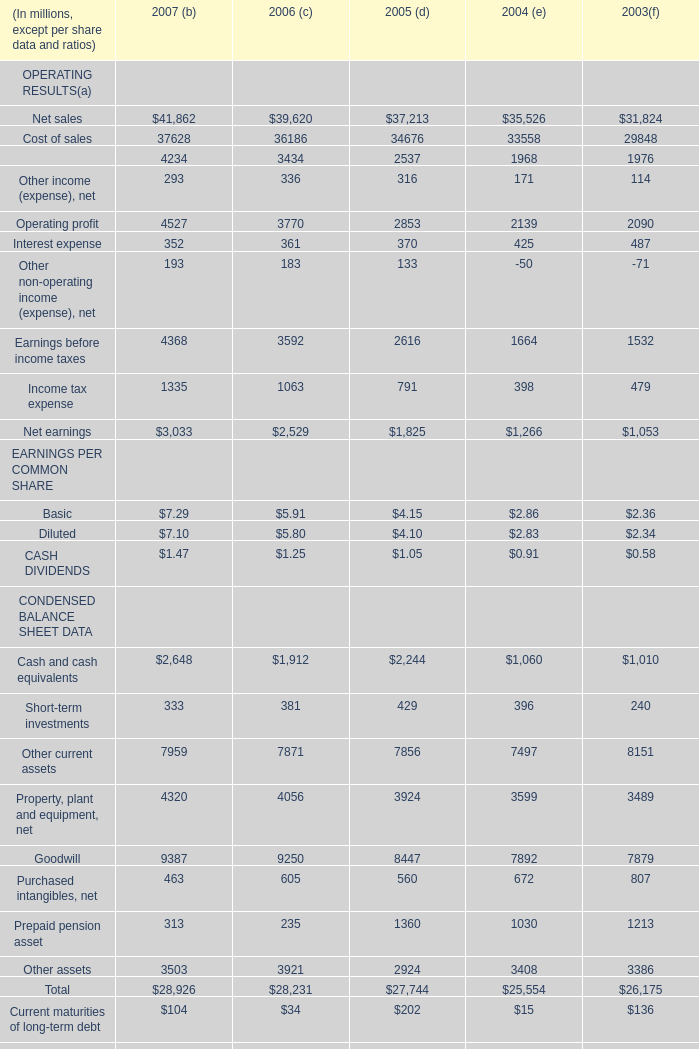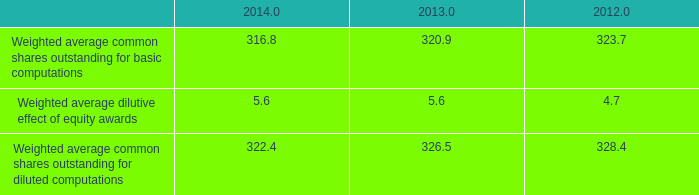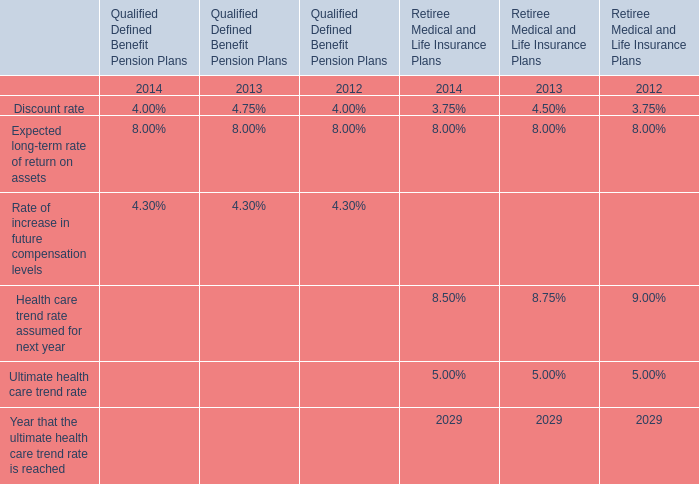In which section the sum of Long-term debt, net has the highest value? 
Answer: 2003. 